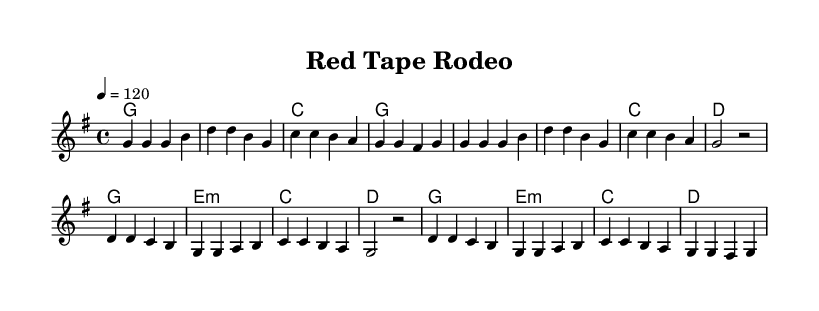What is the key signature of this music? The key signature is G major, which has one sharp (F#). This can be determined by looking at the key signature indication at the beginning of the sheet music.
Answer: G major What is the time signature of this piece? The time signature is 4/4. This is indicated at the start of the music, showing that there are four beats per measure and a quarter note gets one beat.
Answer: 4/4 What is the tempo marking for this piece? The tempo marking is 120 beats per minute, as indicated in the tempo section using the equals sign after the '4'. This denotes how fast the music should be played.
Answer: 120 How many measures are there in the verse section? The verse section consists of eight measures. By counting the grouped sections of music in the melody, we see there are eight distinct measures for the verse.
Answer: 8 What is the chord played in the first measure? The chord played in the first measure is G major, as indicated in the harmonies section aligning with the melody written above it.
Answer: G How does the chorus differ from the verse in terms of chords? The chorus introduces an E minor chord not present in the verse section, which uses only G, C, and D chords. The E minor chord adds a different tonal color to the music, showcasing a common shift in structure used in country rock.
Answer: E minor What thematic element is commonly reflected in the lyrics corresponding to the title "Red Tape Rodeo"? The thematic element reflected in the lyrics would involve criticism of bureaucracy, as suggested by the title which implies frustration with administrative hurdles. This is common in country rock, where themes of rebellion and individualism are prominent.
Answer: Bureaucracy 